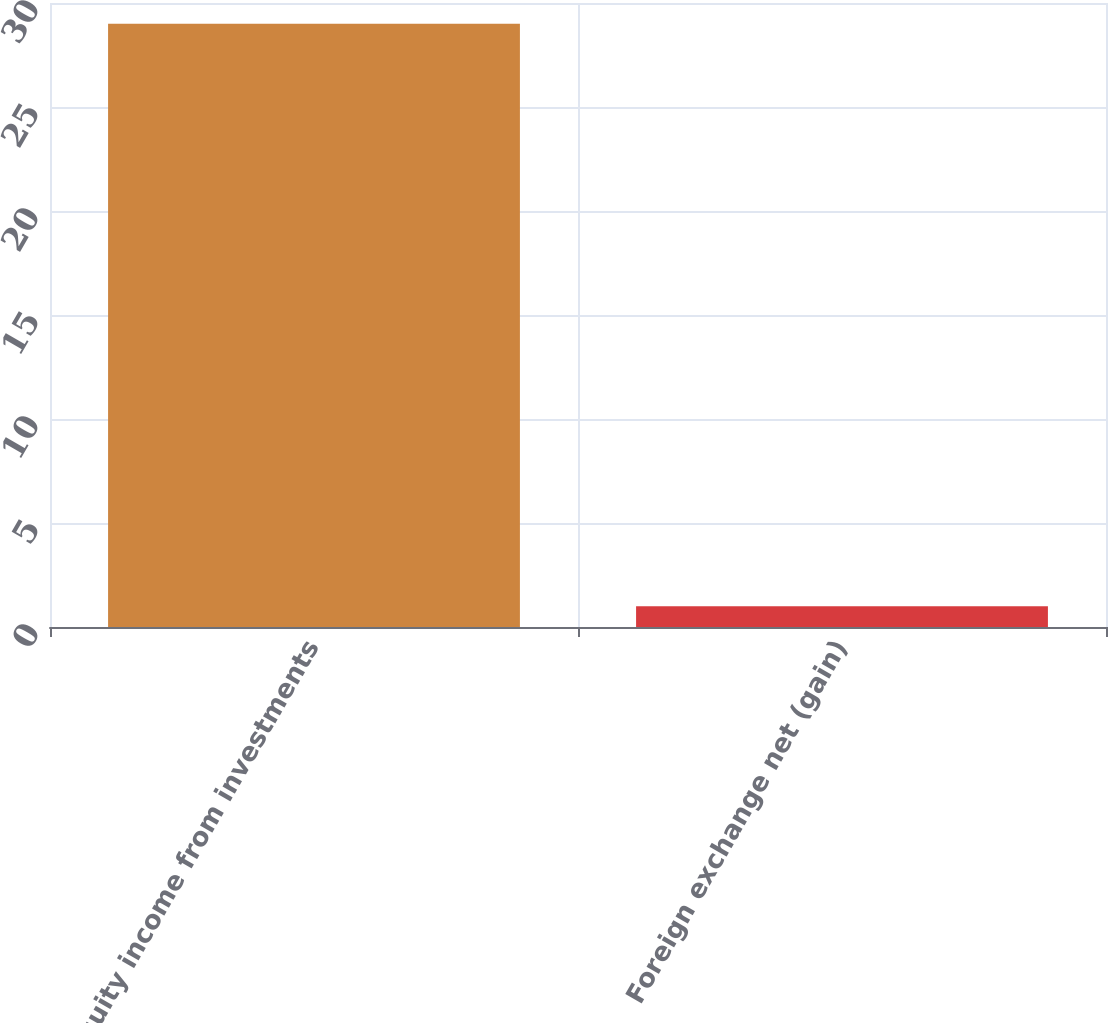<chart> <loc_0><loc_0><loc_500><loc_500><bar_chart><fcel>Equity income from investments<fcel>Foreign exchange net (gain)<nl><fcel>29<fcel>1<nl></chart> 